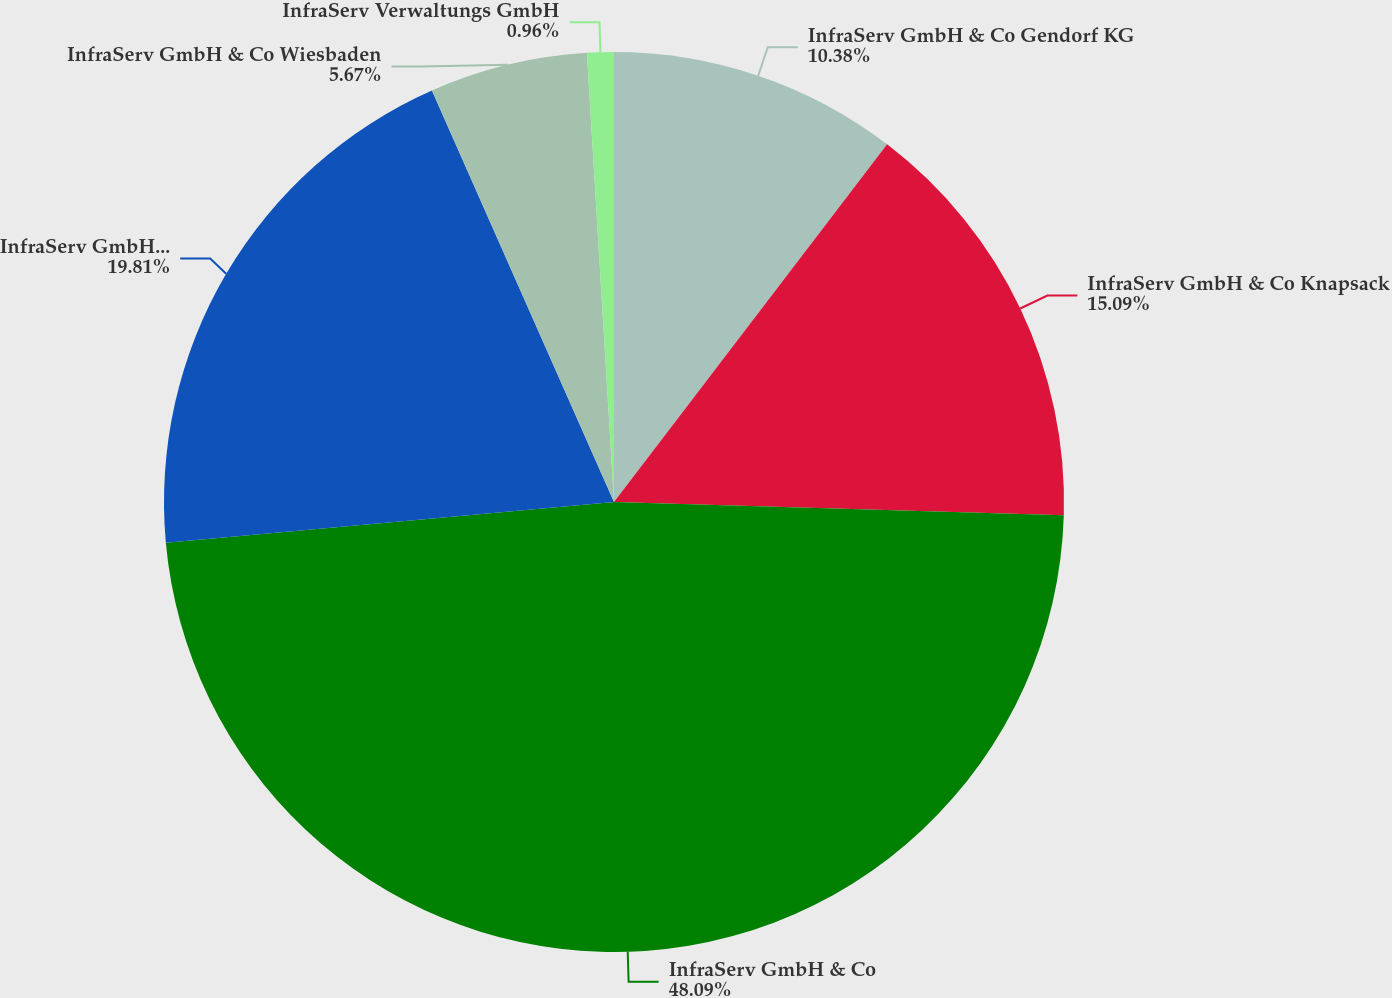<chart> <loc_0><loc_0><loc_500><loc_500><pie_chart><fcel>InfraServ GmbH & Co Gendorf KG<fcel>InfraServ GmbH & Co Knapsack<fcel>InfraServ GmbH & Co<fcel>InfraServ GmbH & Co Hochst KG<fcel>InfraServ GmbH & Co Wiesbaden<fcel>InfraServ Verwaltungs GmbH<nl><fcel>10.38%<fcel>15.09%<fcel>48.09%<fcel>19.81%<fcel>5.67%<fcel>0.96%<nl></chart> 